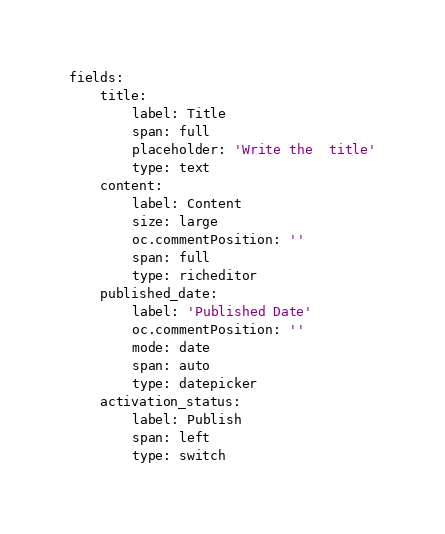<code> <loc_0><loc_0><loc_500><loc_500><_YAML_>fields:
    title:
        label: Title
        span: full
        placeholder: 'Write the  title'
        type: text
    content:
        label: Content
        size: large
        oc.commentPosition: ''
        span: full
        type: richeditor
    published_date:
        label: 'Published Date'
        oc.commentPosition: ''
        mode: date
        span: auto
        type: datepicker
    activation_status:
        label: Publish
        span: left
        type: switch
</code> 